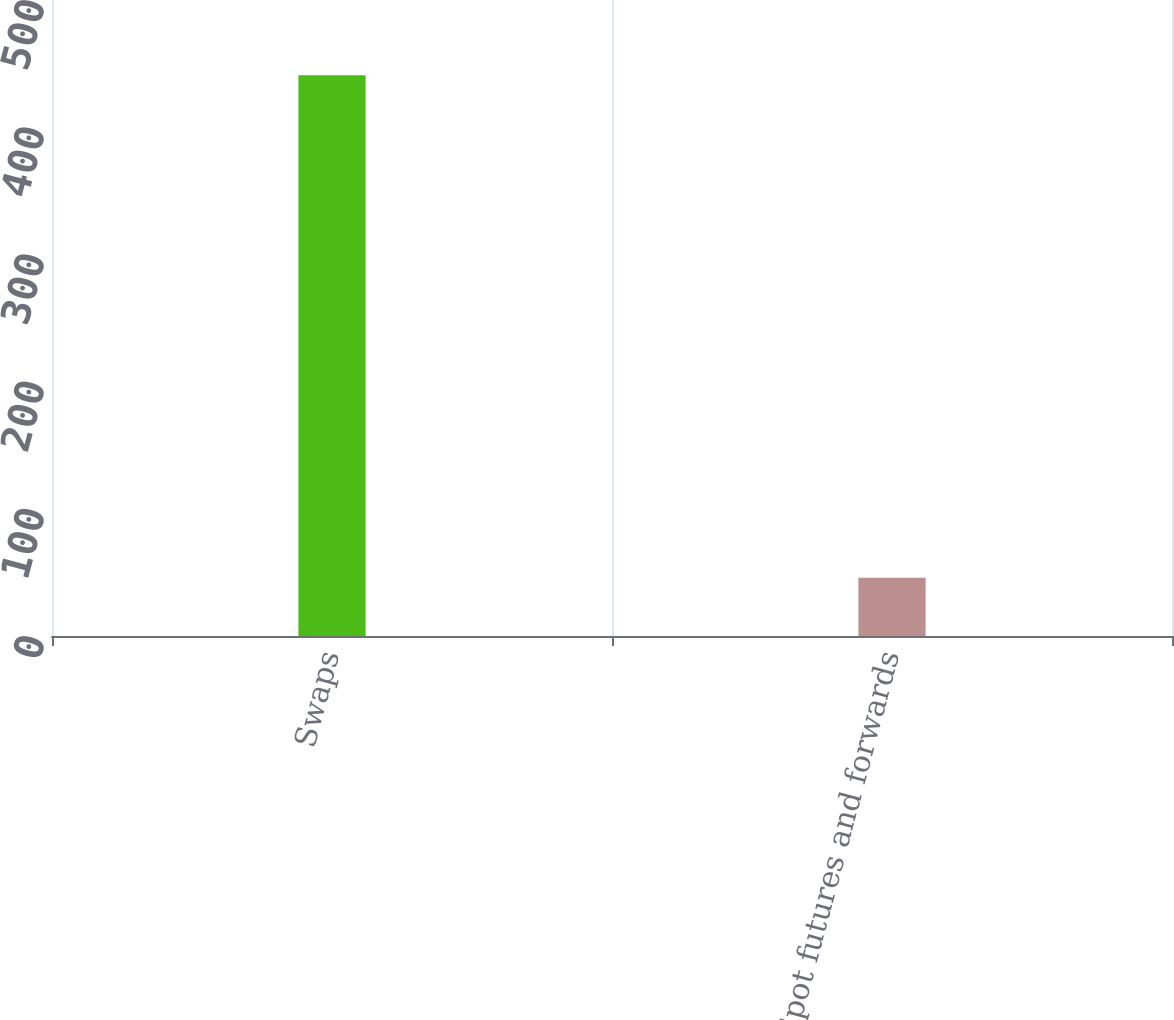Convert chart. <chart><loc_0><loc_0><loc_500><loc_500><bar_chart><fcel>Swaps<fcel>Spot futures and forwards<nl><fcel>440.8<fcel>45.8<nl></chart> 